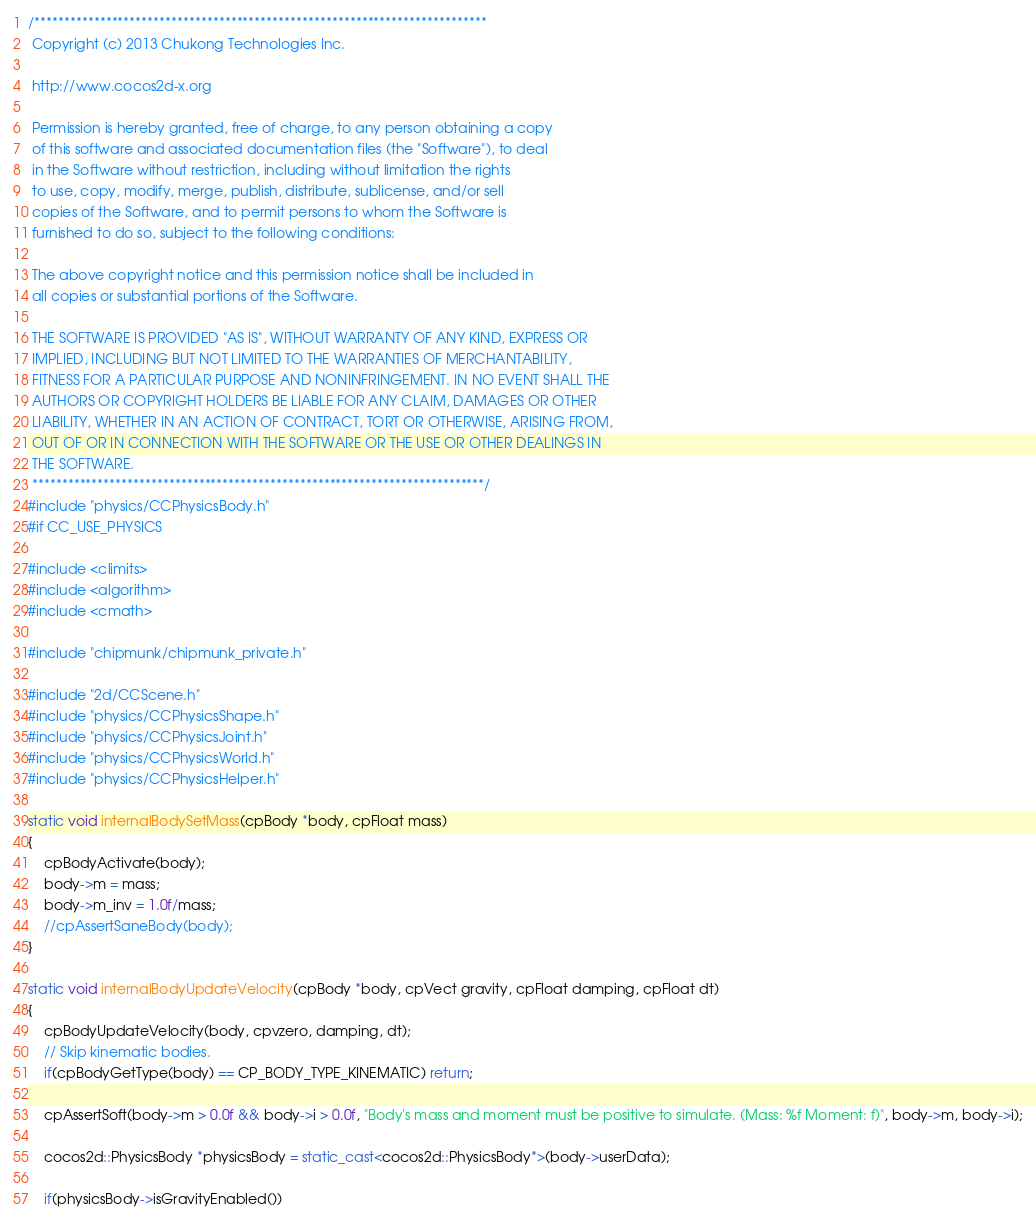Convert code to text. <code><loc_0><loc_0><loc_500><loc_500><_C++_>/****************************************************************************
 Copyright (c) 2013 Chukong Technologies Inc.
 
 http://www.cocos2d-x.org
 
 Permission is hereby granted, free of charge, to any person obtaining a copy
 of this software and associated documentation files (the "Software"), to deal
 in the Software without restriction, including without limitation the rights
 to use, copy, modify, merge, publish, distribute, sublicense, and/or sell
 copies of the Software, and to permit persons to whom the Software is
 furnished to do so, subject to the following conditions:
 
 The above copyright notice and this permission notice shall be included in
 all copies or substantial portions of the Software.
 
 THE SOFTWARE IS PROVIDED "AS IS", WITHOUT WARRANTY OF ANY KIND, EXPRESS OR
 IMPLIED, INCLUDING BUT NOT LIMITED TO THE WARRANTIES OF MERCHANTABILITY,
 FITNESS FOR A PARTICULAR PURPOSE AND NONINFRINGEMENT. IN NO EVENT SHALL THE
 AUTHORS OR COPYRIGHT HOLDERS BE LIABLE FOR ANY CLAIM, DAMAGES OR OTHER
 LIABILITY, WHETHER IN AN ACTION OF CONTRACT, TORT OR OTHERWISE, ARISING FROM,
 OUT OF OR IN CONNECTION WITH THE SOFTWARE OR THE USE OR OTHER DEALINGS IN
 THE SOFTWARE.
 ****************************************************************************/
#include "physics/CCPhysicsBody.h"
#if CC_USE_PHYSICS

#include <climits>
#include <algorithm>
#include <cmath>

#include "chipmunk/chipmunk_private.h"

#include "2d/CCScene.h"
#include "physics/CCPhysicsShape.h"
#include "physics/CCPhysicsJoint.h"
#include "physics/CCPhysicsWorld.h"
#include "physics/CCPhysicsHelper.h"

static void internalBodySetMass(cpBody *body, cpFloat mass)
{
    cpBodyActivate(body);
    body->m = mass;
    body->m_inv = 1.0f/mass;
    //cpAssertSaneBody(body);
}

static void internalBodyUpdateVelocity(cpBody *body, cpVect gravity, cpFloat damping, cpFloat dt)
{
    cpBodyUpdateVelocity(body, cpvzero, damping, dt);
    // Skip kinematic bodies.
    if(cpBodyGetType(body) == CP_BODY_TYPE_KINEMATIC) return;
    
    cpAssertSoft(body->m > 0.0f && body->i > 0.0f, "Body's mass and moment must be positive to simulate. (Mass: %f Moment: f)", body->m, body->i);
    
    cocos2d::PhysicsBody *physicsBody = static_cast<cocos2d::PhysicsBody*>(body->userData);
    
    if(physicsBody->isGravityEnabled())</code> 